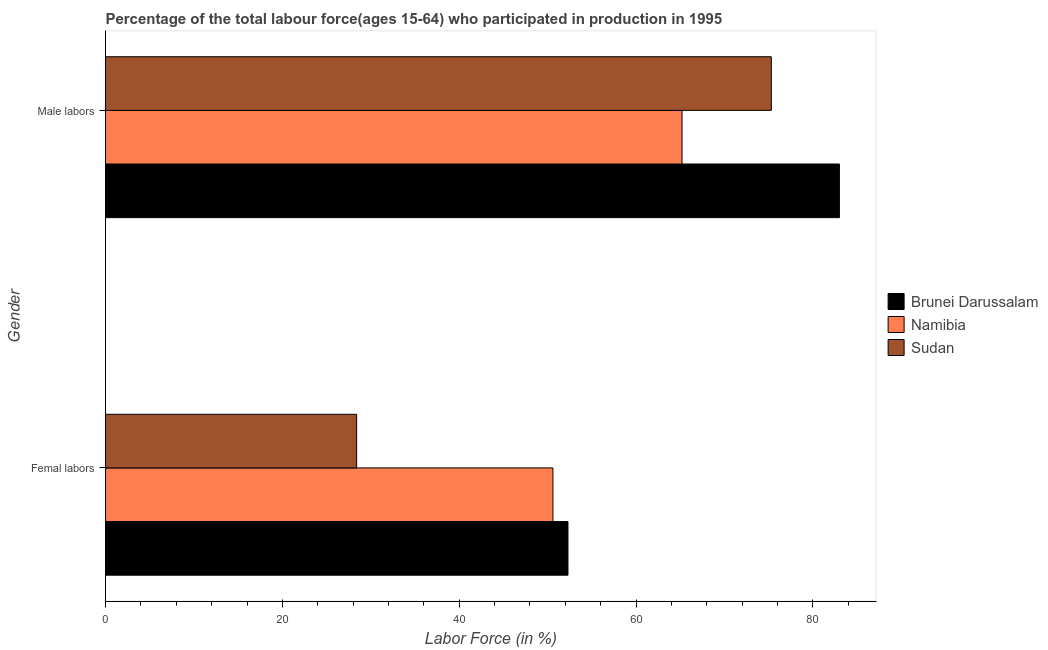Are the number of bars per tick equal to the number of legend labels?
Make the answer very short. Yes. How many bars are there on the 2nd tick from the top?
Provide a short and direct response. 3. How many bars are there on the 1st tick from the bottom?
Provide a short and direct response. 3. What is the label of the 2nd group of bars from the top?
Offer a very short reply. Femal labors. What is the percentage of male labour force in Sudan?
Your response must be concise. 75.3. Across all countries, what is the maximum percentage of male labour force?
Give a very brief answer. 83. Across all countries, what is the minimum percentage of male labour force?
Your answer should be compact. 65.2. In which country was the percentage of male labour force maximum?
Provide a succinct answer. Brunei Darussalam. In which country was the percentage of female labor force minimum?
Ensure brevity in your answer.  Sudan. What is the total percentage of female labor force in the graph?
Your answer should be compact. 131.3. What is the difference between the percentage of female labor force in Brunei Darussalam and that in Namibia?
Keep it short and to the point. 1.7. What is the difference between the percentage of male labour force in Sudan and the percentage of female labor force in Namibia?
Offer a terse response. 24.7. What is the average percentage of male labour force per country?
Offer a very short reply. 74.5. What is the difference between the percentage of female labor force and percentage of male labour force in Sudan?
Provide a succinct answer. -46.9. What is the ratio of the percentage of male labour force in Namibia to that in Sudan?
Offer a terse response. 0.87. In how many countries, is the percentage of male labour force greater than the average percentage of male labour force taken over all countries?
Provide a short and direct response. 2. What does the 2nd bar from the top in Male labors represents?
Make the answer very short. Namibia. What does the 1st bar from the bottom in Male labors represents?
Your response must be concise. Brunei Darussalam. How many bars are there?
Your response must be concise. 6. Are all the bars in the graph horizontal?
Provide a short and direct response. Yes. How are the legend labels stacked?
Your response must be concise. Vertical. What is the title of the graph?
Give a very brief answer. Percentage of the total labour force(ages 15-64) who participated in production in 1995. What is the Labor Force (in %) in Brunei Darussalam in Femal labors?
Offer a very short reply. 52.3. What is the Labor Force (in %) of Namibia in Femal labors?
Ensure brevity in your answer.  50.6. What is the Labor Force (in %) of Sudan in Femal labors?
Ensure brevity in your answer.  28.4. What is the Labor Force (in %) in Brunei Darussalam in Male labors?
Offer a terse response. 83. What is the Labor Force (in %) of Namibia in Male labors?
Your answer should be very brief. 65.2. What is the Labor Force (in %) of Sudan in Male labors?
Provide a short and direct response. 75.3. Across all Gender, what is the maximum Labor Force (in %) of Namibia?
Give a very brief answer. 65.2. Across all Gender, what is the maximum Labor Force (in %) of Sudan?
Provide a short and direct response. 75.3. Across all Gender, what is the minimum Labor Force (in %) in Brunei Darussalam?
Provide a short and direct response. 52.3. Across all Gender, what is the minimum Labor Force (in %) of Namibia?
Offer a terse response. 50.6. Across all Gender, what is the minimum Labor Force (in %) of Sudan?
Keep it short and to the point. 28.4. What is the total Labor Force (in %) in Brunei Darussalam in the graph?
Keep it short and to the point. 135.3. What is the total Labor Force (in %) in Namibia in the graph?
Offer a terse response. 115.8. What is the total Labor Force (in %) in Sudan in the graph?
Ensure brevity in your answer.  103.7. What is the difference between the Labor Force (in %) in Brunei Darussalam in Femal labors and that in Male labors?
Provide a short and direct response. -30.7. What is the difference between the Labor Force (in %) of Namibia in Femal labors and that in Male labors?
Your answer should be compact. -14.6. What is the difference between the Labor Force (in %) of Sudan in Femal labors and that in Male labors?
Offer a very short reply. -46.9. What is the difference between the Labor Force (in %) in Brunei Darussalam in Femal labors and the Labor Force (in %) in Namibia in Male labors?
Offer a terse response. -12.9. What is the difference between the Labor Force (in %) in Brunei Darussalam in Femal labors and the Labor Force (in %) in Sudan in Male labors?
Make the answer very short. -23. What is the difference between the Labor Force (in %) of Namibia in Femal labors and the Labor Force (in %) of Sudan in Male labors?
Provide a short and direct response. -24.7. What is the average Labor Force (in %) in Brunei Darussalam per Gender?
Ensure brevity in your answer.  67.65. What is the average Labor Force (in %) of Namibia per Gender?
Offer a very short reply. 57.9. What is the average Labor Force (in %) of Sudan per Gender?
Ensure brevity in your answer.  51.85. What is the difference between the Labor Force (in %) in Brunei Darussalam and Labor Force (in %) in Sudan in Femal labors?
Provide a short and direct response. 23.9. What is the difference between the Labor Force (in %) in Namibia and Labor Force (in %) in Sudan in Femal labors?
Provide a succinct answer. 22.2. What is the difference between the Labor Force (in %) in Brunei Darussalam and Labor Force (in %) in Namibia in Male labors?
Give a very brief answer. 17.8. What is the difference between the Labor Force (in %) of Brunei Darussalam and Labor Force (in %) of Sudan in Male labors?
Make the answer very short. 7.7. What is the ratio of the Labor Force (in %) in Brunei Darussalam in Femal labors to that in Male labors?
Provide a succinct answer. 0.63. What is the ratio of the Labor Force (in %) of Namibia in Femal labors to that in Male labors?
Provide a succinct answer. 0.78. What is the ratio of the Labor Force (in %) of Sudan in Femal labors to that in Male labors?
Make the answer very short. 0.38. What is the difference between the highest and the second highest Labor Force (in %) in Brunei Darussalam?
Provide a short and direct response. 30.7. What is the difference between the highest and the second highest Labor Force (in %) of Namibia?
Your answer should be compact. 14.6. What is the difference between the highest and the second highest Labor Force (in %) of Sudan?
Your response must be concise. 46.9. What is the difference between the highest and the lowest Labor Force (in %) in Brunei Darussalam?
Your answer should be very brief. 30.7. What is the difference between the highest and the lowest Labor Force (in %) in Sudan?
Your answer should be very brief. 46.9. 